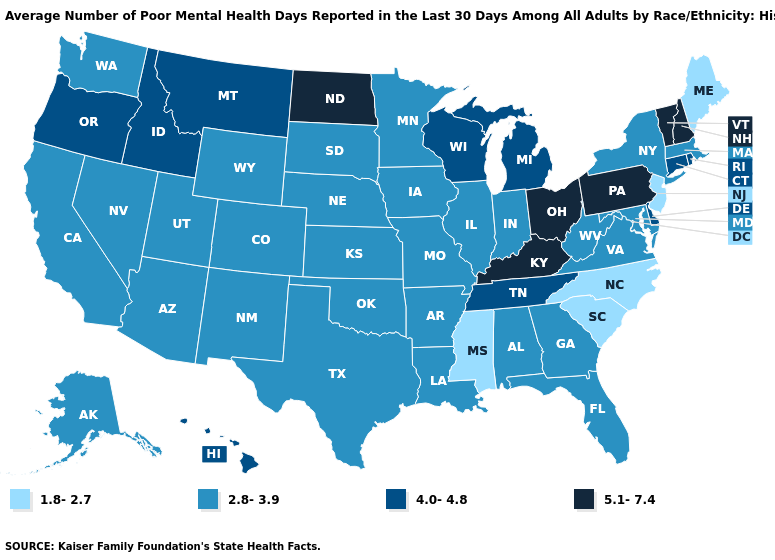What is the highest value in the USA?
Concise answer only. 5.1-7.4. What is the lowest value in states that border Wyoming?
Short answer required. 2.8-3.9. What is the highest value in the USA?
Concise answer only. 5.1-7.4. Among the states that border Ohio , does Kentucky have the highest value?
Answer briefly. Yes. Name the states that have a value in the range 5.1-7.4?
Quick response, please. Kentucky, New Hampshire, North Dakota, Ohio, Pennsylvania, Vermont. Does Montana have the lowest value in the West?
Quick response, please. No. What is the value of Nevada?
Be succinct. 2.8-3.9. Which states have the lowest value in the USA?
Answer briefly. Maine, Mississippi, New Jersey, North Carolina, South Carolina. Name the states that have a value in the range 4.0-4.8?
Keep it brief. Connecticut, Delaware, Hawaii, Idaho, Michigan, Montana, Oregon, Rhode Island, Tennessee, Wisconsin. Is the legend a continuous bar?
Write a very short answer. No. What is the value of Delaware?
Write a very short answer. 4.0-4.8. Name the states that have a value in the range 1.8-2.7?
Quick response, please. Maine, Mississippi, New Jersey, North Carolina, South Carolina. What is the value of Ohio?
Short answer required. 5.1-7.4. Does Virginia have a lower value than South Dakota?
Give a very brief answer. No. Does Kentucky have a higher value than New Hampshire?
Answer briefly. No. 